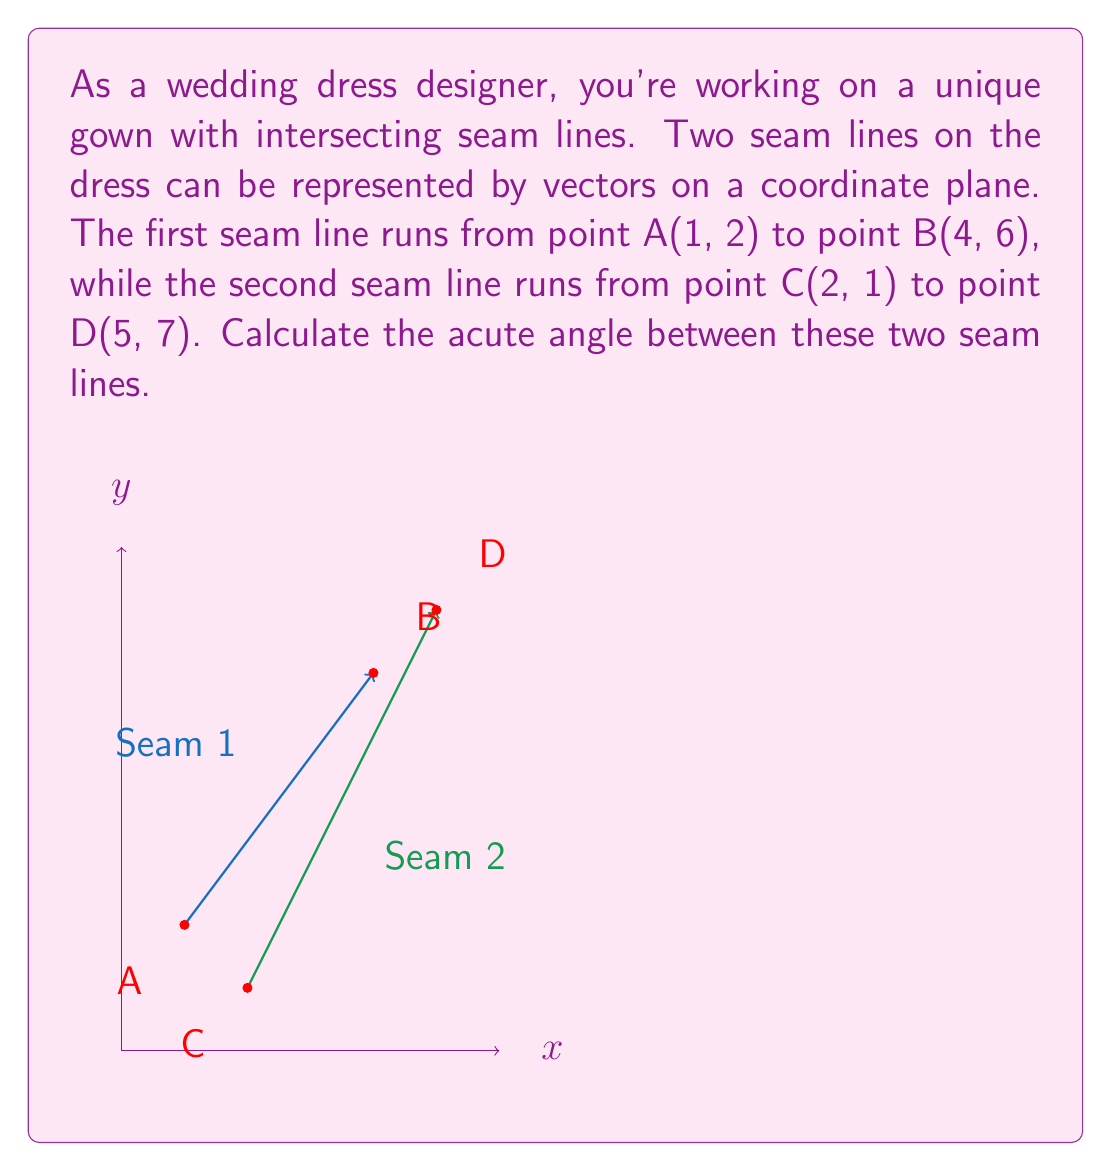Help me with this question. To find the angle between two vectors, we can use the dot product formula:

$$\cos \theta = \frac{\vec{v_1} \cdot \vec{v_2}}{|\vec{v_1}||\vec{v_2}|}$$

Step 1: Find the vectors $\vec{v_1}$ and $\vec{v_2}$
$\vec{v_1} = \overrightarrow{AB} = (4-1, 6-2) = (3, 4)$
$\vec{v_2} = \overrightarrow{CD} = (5-2, 7-1) = (3, 6)$

Step 2: Calculate the dot product $\vec{v_1} \cdot \vec{v_2}$
$\vec{v_1} \cdot \vec{v_2} = (3 \times 3) + (4 \times 6) = 9 + 24 = 33$

Step 3: Calculate the magnitudes $|\vec{v_1}|$ and $|\vec{v_2}|$
$|\vec{v_1}| = \sqrt{3^2 + 4^2} = \sqrt{25} = 5$
$|\vec{v_2}| = \sqrt{3^2 + 6^2} = \sqrt{45} = 3\sqrt{5}$

Step 4: Apply the dot product formula
$$\cos \theta = \frac{33}{5 \times 3\sqrt{5}} = \frac{11}{5\sqrt{5}}$$

Step 5: Take the inverse cosine (arccos) of both sides
$$\theta = \arccos(\frac{11}{5\sqrt{5}})$$

Step 6: Calculate the result (in degrees)
$\theta \approx 22.33°$
Answer: $22.33°$ 